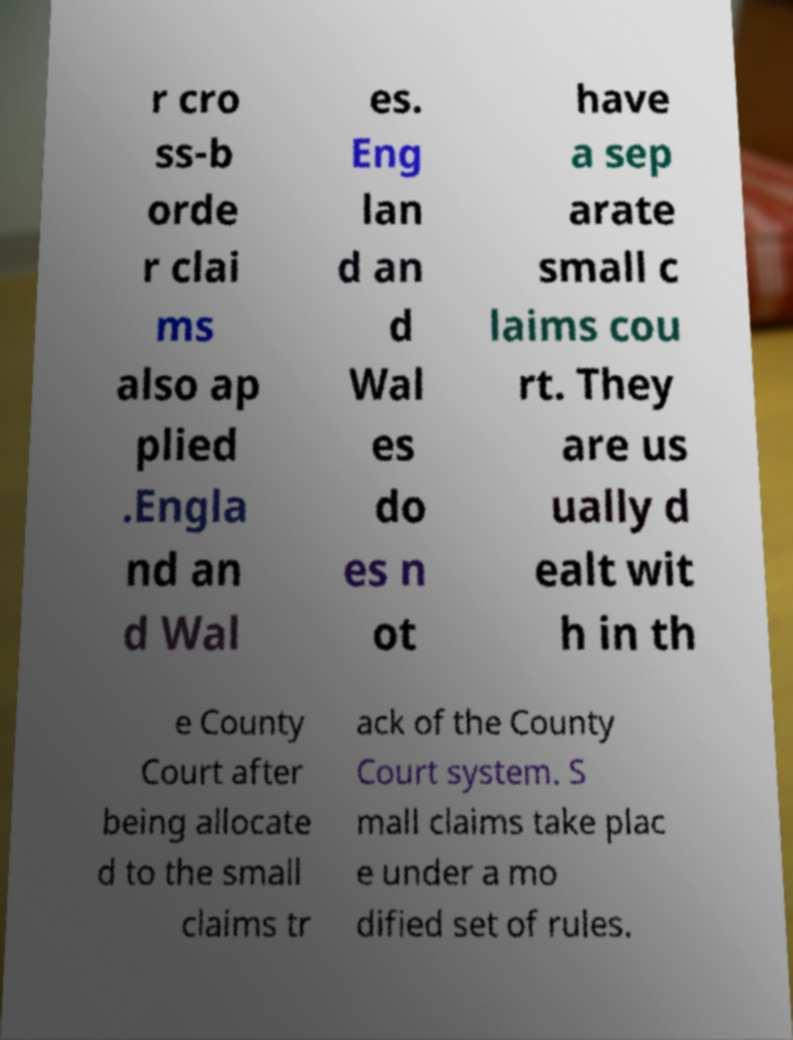I need the written content from this picture converted into text. Can you do that? r cro ss-b orde r clai ms also ap plied .Engla nd an d Wal es. Eng lan d an d Wal es do es n ot have a sep arate small c laims cou rt. They are us ually d ealt wit h in th e County Court after being allocate d to the small claims tr ack of the County Court system. S mall claims take plac e under a mo dified set of rules. 